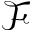<formula> <loc_0><loc_0><loc_500><loc_500>\mathcal { F }</formula> 